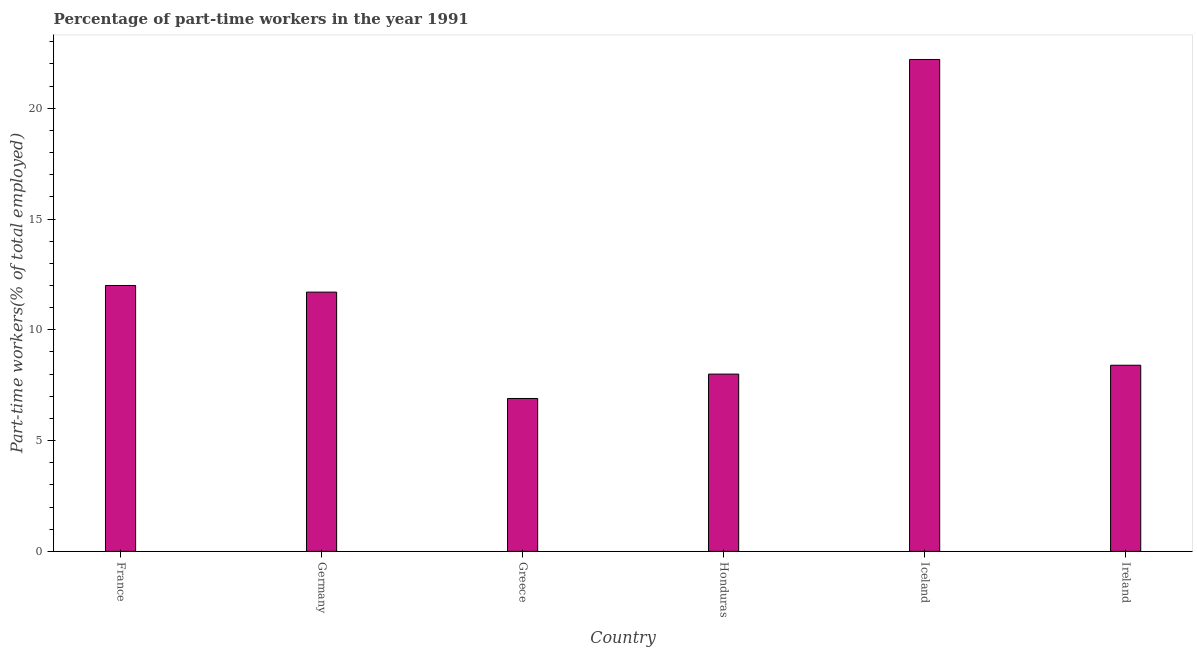Does the graph contain grids?
Your answer should be very brief. No. What is the title of the graph?
Provide a short and direct response. Percentage of part-time workers in the year 1991. What is the label or title of the Y-axis?
Provide a succinct answer. Part-time workers(% of total employed). What is the percentage of part-time workers in Greece?
Your answer should be compact. 6.9. Across all countries, what is the maximum percentage of part-time workers?
Your answer should be very brief. 22.2. Across all countries, what is the minimum percentage of part-time workers?
Provide a succinct answer. 6.9. In which country was the percentage of part-time workers maximum?
Ensure brevity in your answer.  Iceland. What is the sum of the percentage of part-time workers?
Your response must be concise. 69.2. What is the difference between the percentage of part-time workers in Greece and Honduras?
Give a very brief answer. -1.1. What is the average percentage of part-time workers per country?
Your answer should be compact. 11.53. What is the median percentage of part-time workers?
Offer a very short reply. 10.05. In how many countries, is the percentage of part-time workers greater than 20 %?
Give a very brief answer. 1. What is the ratio of the percentage of part-time workers in Germany to that in Iceland?
Your answer should be compact. 0.53. Is the difference between the percentage of part-time workers in Germany and Honduras greater than the difference between any two countries?
Keep it short and to the point. No. Is the sum of the percentage of part-time workers in Germany and Honduras greater than the maximum percentage of part-time workers across all countries?
Your answer should be very brief. No. What is the difference between the highest and the lowest percentage of part-time workers?
Your response must be concise. 15.3. In how many countries, is the percentage of part-time workers greater than the average percentage of part-time workers taken over all countries?
Give a very brief answer. 3. How many bars are there?
Offer a very short reply. 6. Are all the bars in the graph horizontal?
Offer a very short reply. No. What is the difference between two consecutive major ticks on the Y-axis?
Your answer should be very brief. 5. What is the Part-time workers(% of total employed) in Germany?
Your response must be concise. 11.7. What is the Part-time workers(% of total employed) of Greece?
Make the answer very short. 6.9. What is the Part-time workers(% of total employed) of Iceland?
Provide a succinct answer. 22.2. What is the Part-time workers(% of total employed) in Ireland?
Offer a terse response. 8.4. What is the difference between the Part-time workers(% of total employed) in France and Honduras?
Keep it short and to the point. 4. What is the difference between the Part-time workers(% of total employed) in France and Iceland?
Your answer should be compact. -10.2. What is the difference between the Part-time workers(% of total employed) in Greece and Iceland?
Give a very brief answer. -15.3. What is the difference between the Part-time workers(% of total employed) in Honduras and Iceland?
Keep it short and to the point. -14.2. What is the difference between the Part-time workers(% of total employed) in Honduras and Ireland?
Give a very brief answer. -0.4. What is the ratio of the Part-time workers(% of total employed) in France to that in Germany?
Offer a very short reply. 1.03. What is the ratio of the Part-time workers(% of total employed) in France to that in Greece?
Keep it short and to the point. 1.74. What is the ratio of the Part-time workers(% of total employed) in France to that in Honduras?
Give a very brief answer. 1.5. What is the ratio of the Part-time workers(% of total employed) in France to that in Iceland?
Ensure brevity in your answer.  0.54. What is the ratio of the Part-time workers(% of total employed) in France to that in Ireland?
Your answer should be very brief. 1.43. What is the ratio of the Part-time workers(% of total employed) in Germany to that in Greece?
Provide a short and direct response. 1.7. What is the ratio of the Part-time workers(% of total employed) in Germany to that in Honduras?
Keep it short and to the point. 1.46. What is the ratio of the Part-time workers(% of total employed) in Germany to that in Iceland?
Give a very brief answer. 0.53. What is the ratio of the Part-time workers(% of total employed) in Germany to that in Ireland?
Your response must be concise. 1.39. What is the ratio of the Part-time workers(% of total employed) in Greece to that in Honduras?
Provide a short and direct response. 0.86. What is the ratio of the Part-time workers(% of total employed) in Greece to that in Iceland?
Keep it short and to the point. 0.31. What is the ratio of the Part-time workers(% of total employed) in Greece to that in Ireland?
Make the answer very short. 0.82. What is the ratio of the Part-time workers(% of total employed) in Honduras to that in Iceland?
Your answer should be compact. 0.36. What is the ratio of the Part-time workers(% of total employed) in Iceland to that in Ireland?
Make the answer very short. 2.64. 